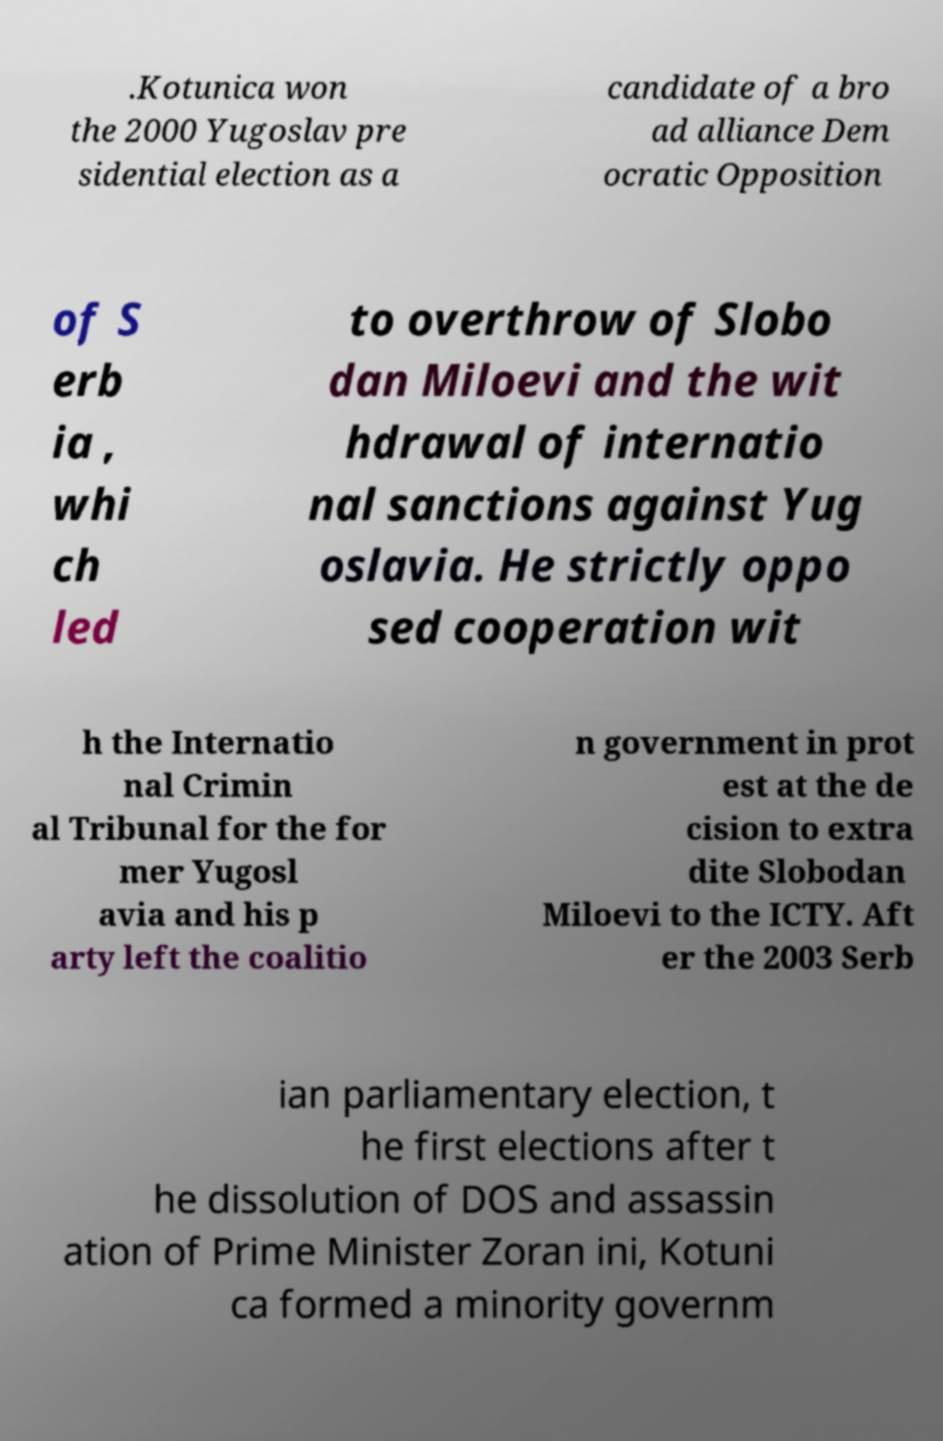What messages or text are displayed in this image? I need them in a readable, typed format. .Kotunica won the 2000 Yugoslav pre sidential election as a candidate of a bro ad alliance Dem ocratic Opposition of S erb ia , whi ch led to overthrow of Slobo dan Miloevi and the wit hdrawal of internatio nal sanctions against Yug oslavia. He strictly oppo sed cooperation wit h the Internatio nal Crimin al Tribunal for the for mer Yugosl avia and his p arty left the coalitio n government in prot est at the de cision to extra dite Slobodan Miloevi to the ICTY. Aft er the 2003 Serb ian parliamentary election, t he first elections after t he dissolution of DOS and assassin ation of Prime Minister Zoran ini, Kotuni ca formed a minority governm 